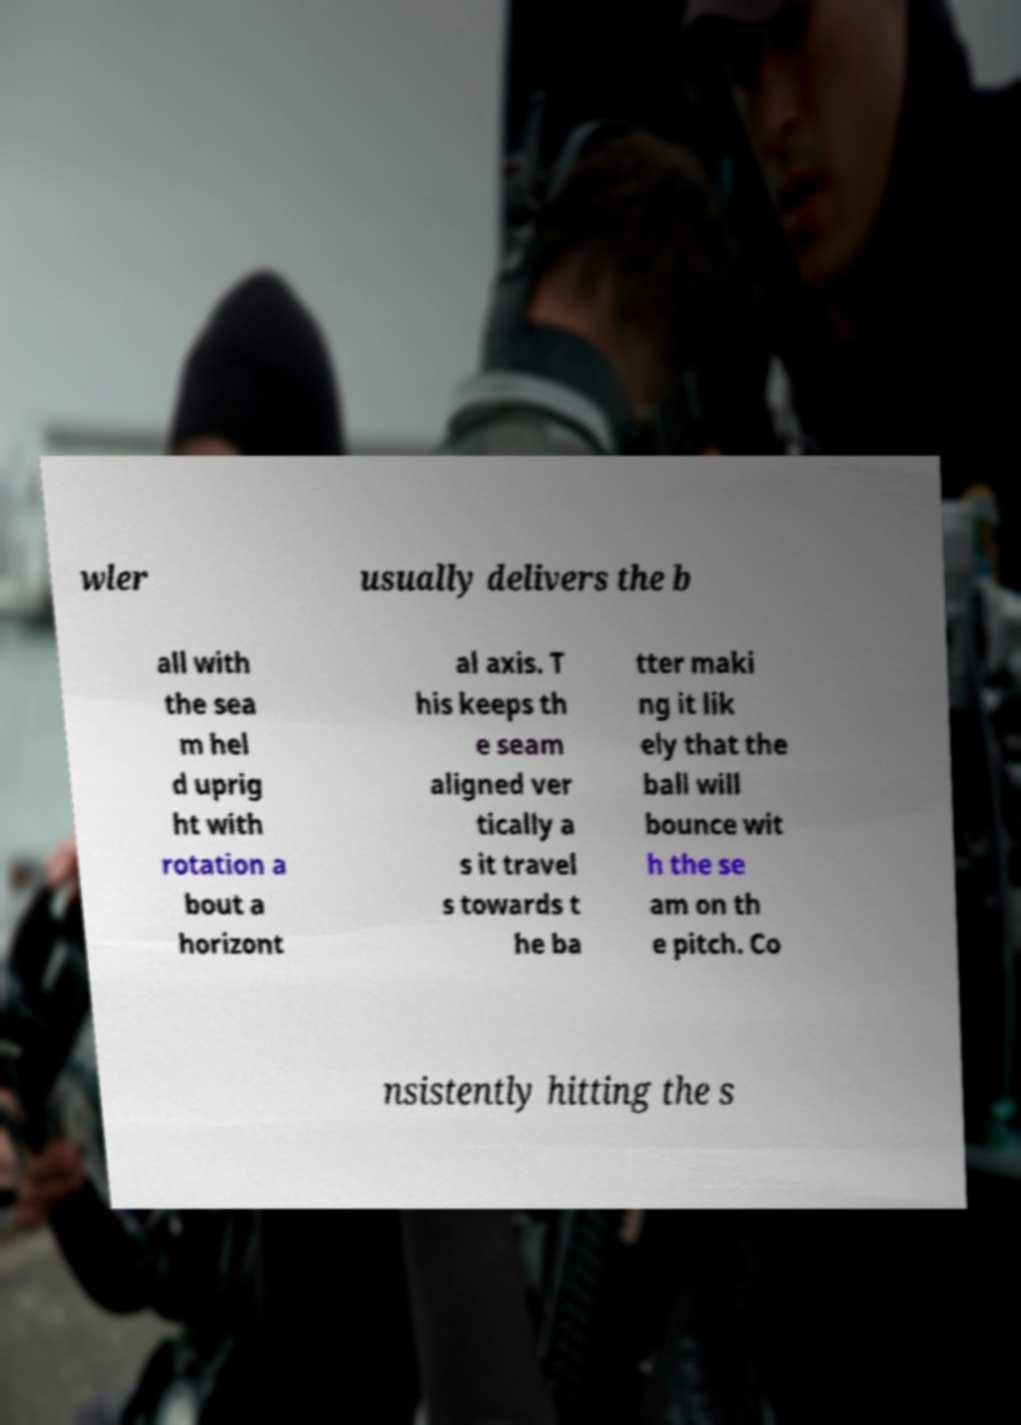Could you extract and type out the text from this image? wler usually delivers the b all with the sea m hel d uprig ht with rotation a bout a horizont al axis. T his keeps th e seam aligned ver tically a s it travel s towards t he ba tter maki ng it lik ely that the ball will bounce wit h the se am on th e pitch. Co nsistently hitting the s 